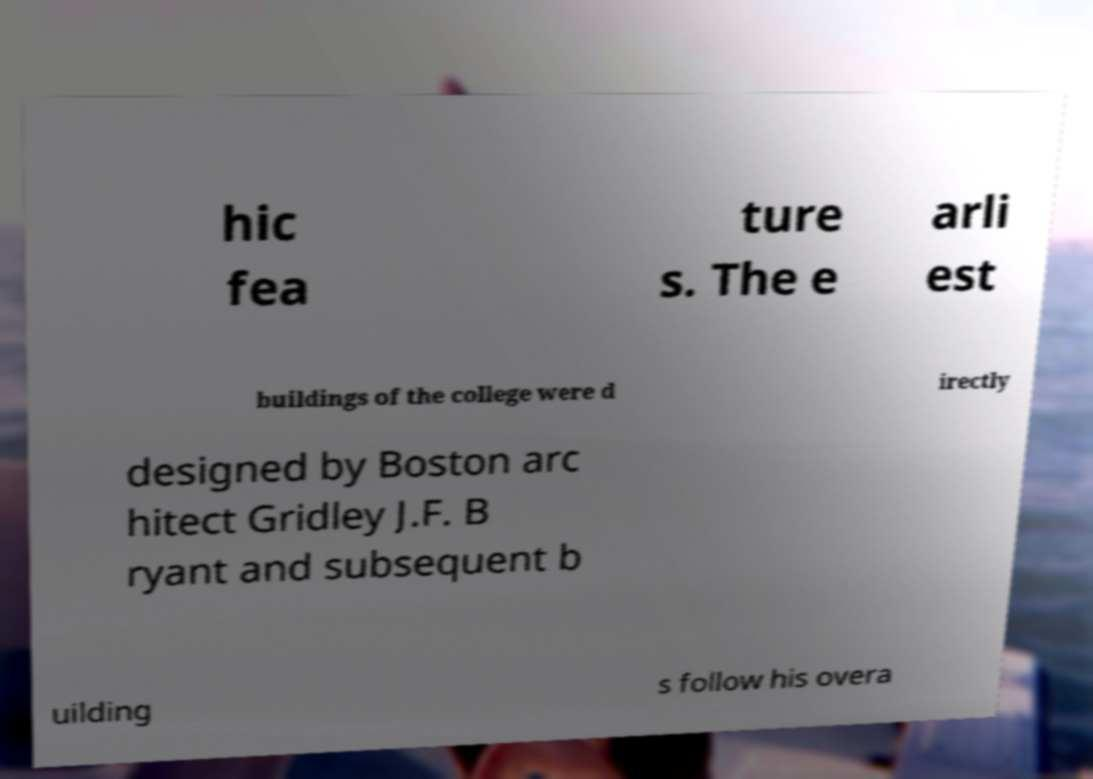For documentation purposes, I need the text within this image transcribed. Could you provide that? hic fea ture s. The e arli est buildings of the college were d irectly designed by Boston arc hitect Gridley J.F. B ryant and subsequent b uilding s follow his overa 